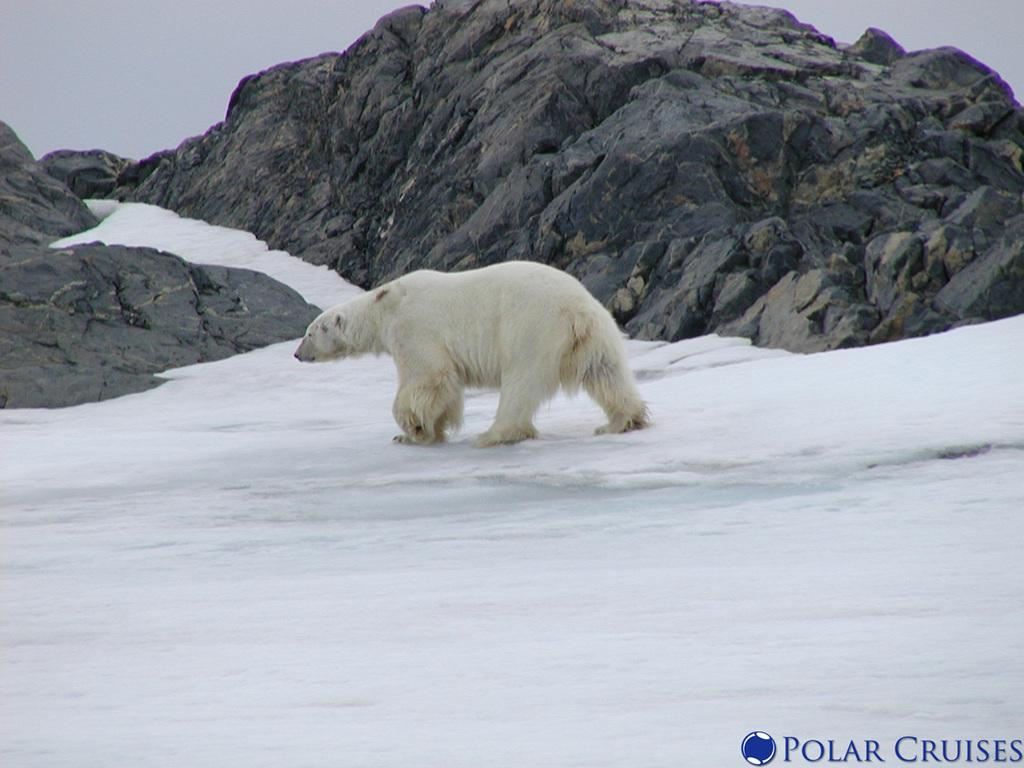What animal is the main subject of the picture? There is a polar bear in the picture. What is the polar bear doing in the image? The polar bear is walking on the snow. What body parts does the polar bear have for walking? The polar bear has paws for walking. What can be seen in the background of the picture? There are rocks in the background of the picture. How is the sky depicted in the image? The sky is clear in the image. How many light bulbs are hanging from the polar bear's paws in the image? There are no light bulbs present in the image; the polar bear is walking on the snow with its paws. 